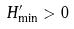<formula> <loc_0><loc_0><loc_500><loc_500>H _ { \min } ^ { \prime } > 0</formula> 